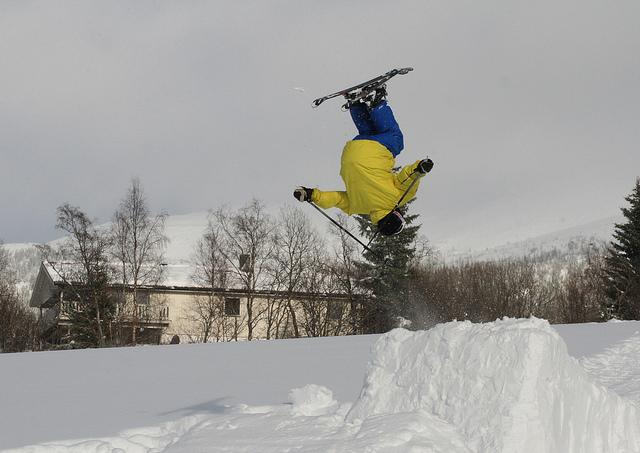What's beyond the house?
Quick response, please. Mountain. Is the person upside down?
Short answer required. Yes. Is the person skiing?
Quick response, please. Yes. What is the person doing?
Write a very short answer. Skiing. 